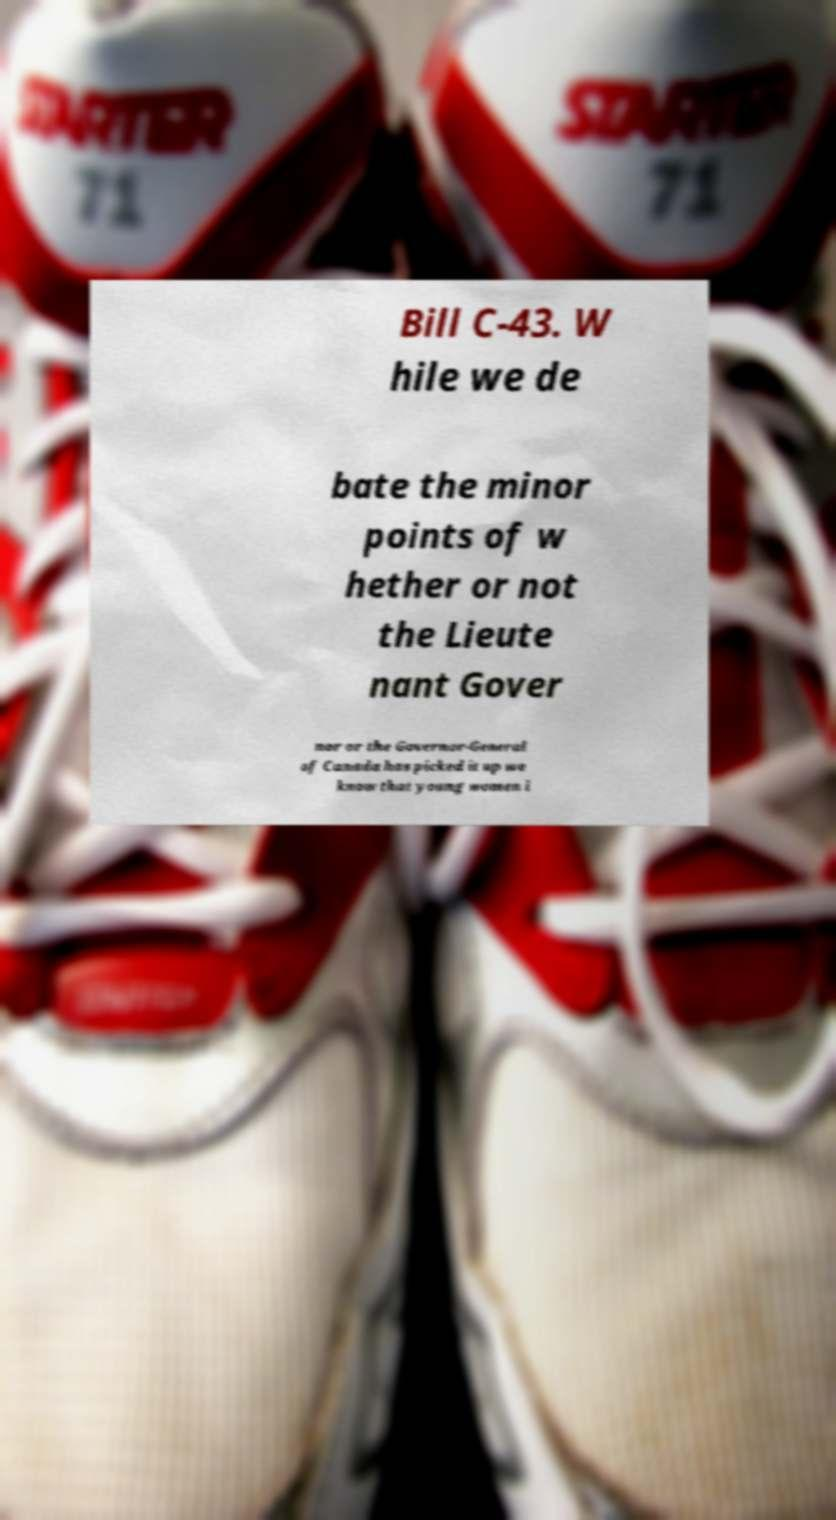Could you extract and type out the text from this image? Bill C-43. W hile we de bate the minor points of w hether or not the Lieute nant Gover nor or the Governor-General of Canada has picked it up we know that young women i 